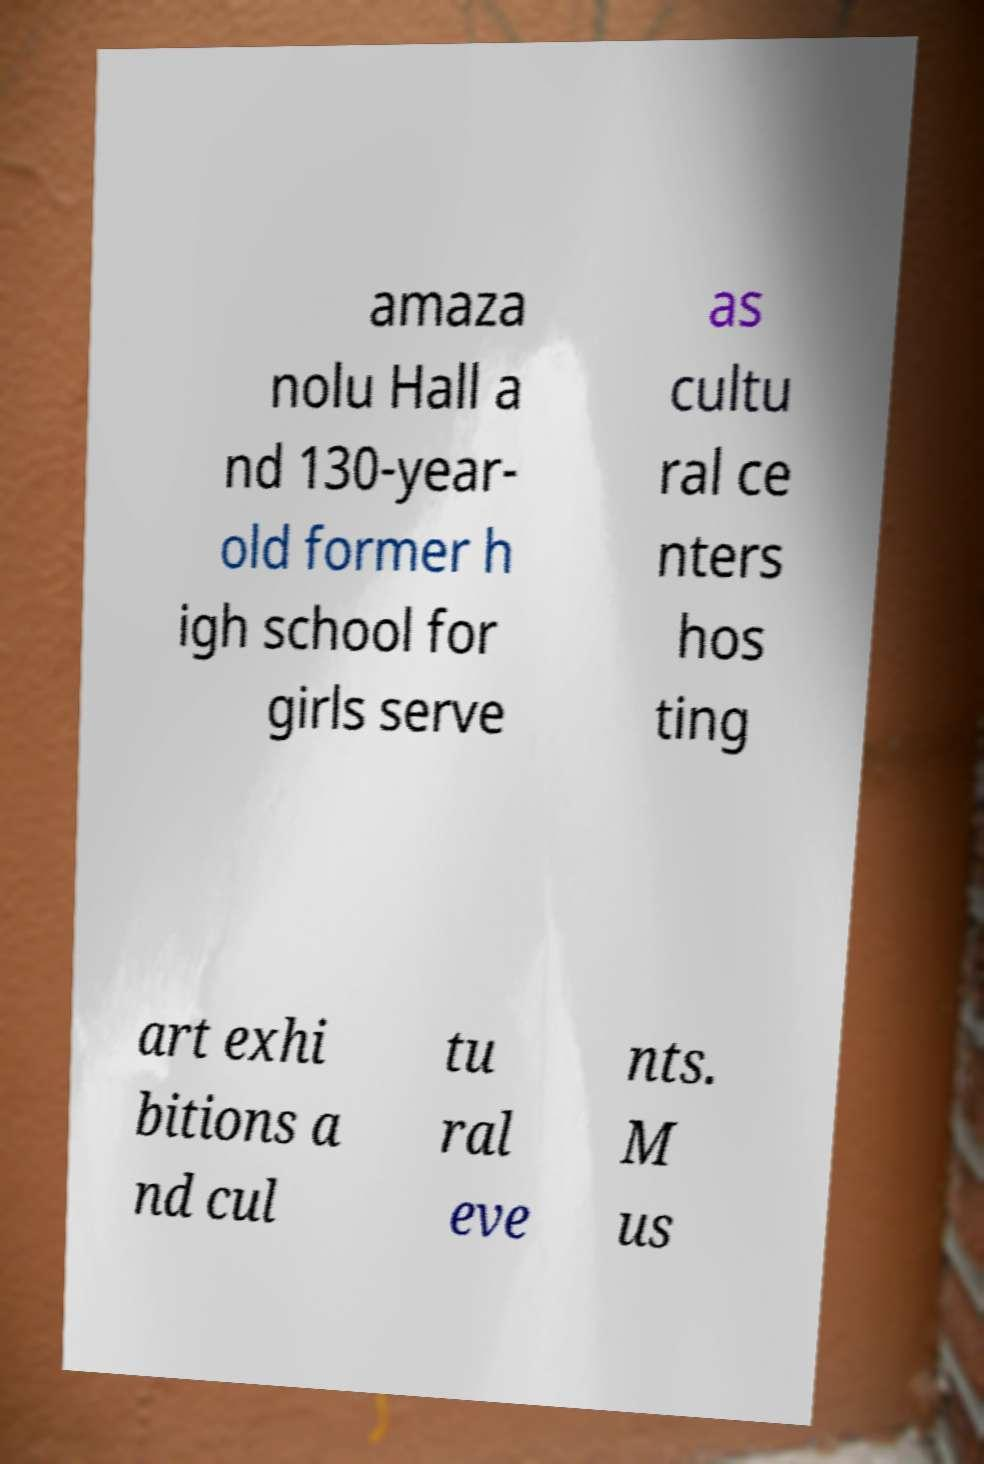For documentation purposes, I need the text within this image transcribed. Could you provide that? amaza nolu Hall a nd 130-year- old former h igh school for girls serve as cultu ral ce nters hos ting art exhi bitions a nd cul tu ral eve nts. M us 